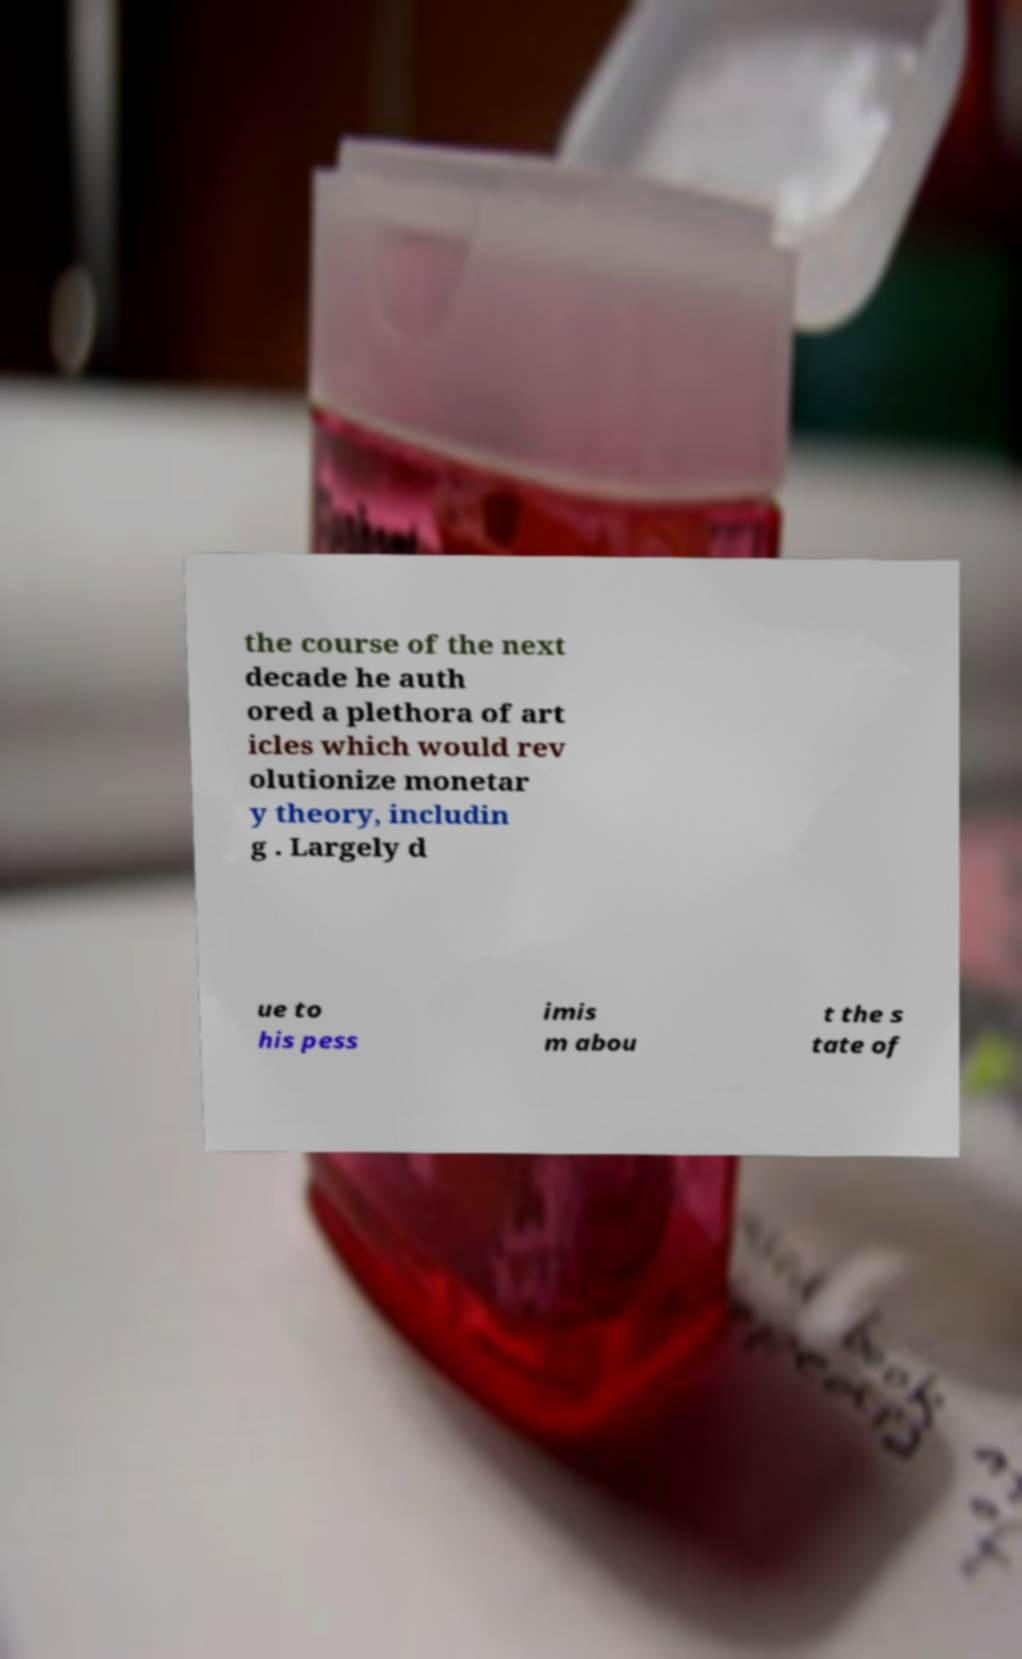Can you accurately transcribe the text from the provided image for me? the course of the next decade he auth ored a plethora of art icles which would rev olutionize monetar y theory, includin g . Largely d ue to his pess imis m abou t the s tate of 